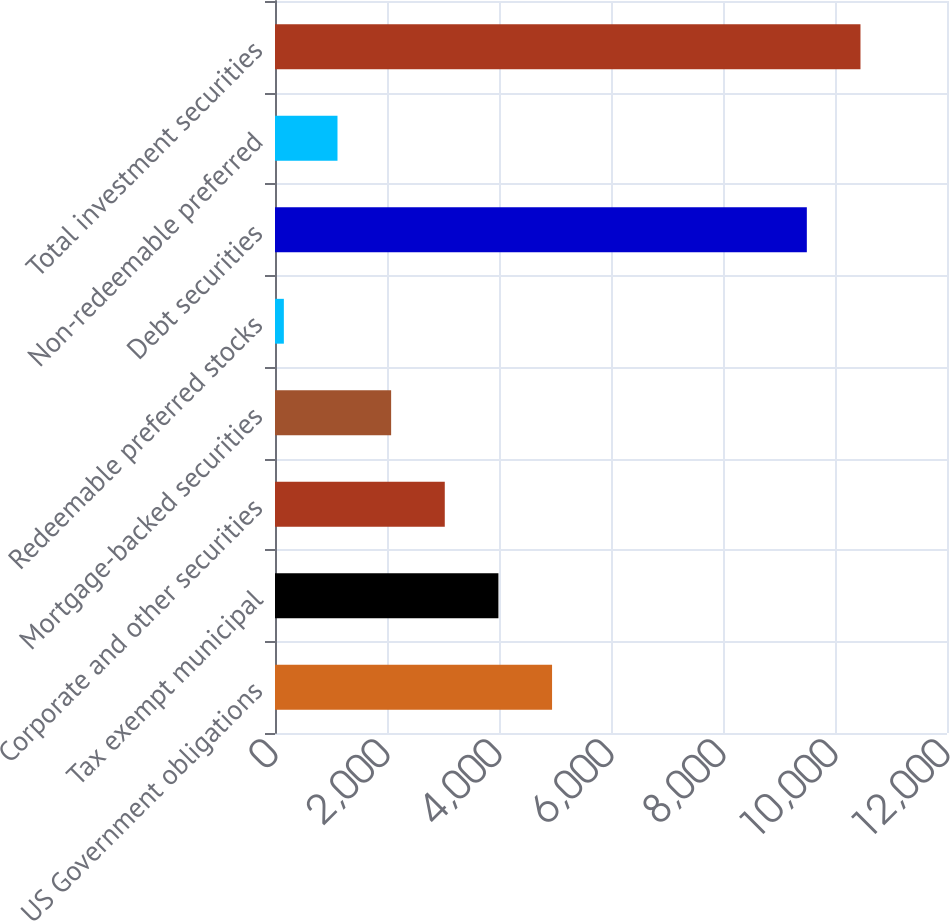<chart> <loc_0><loc_0><loc_500><loc_500><bar_chart><fcel>US Government obligations<fcel>Tax exempt municipal<fcel>Corporate and other securities<fcel>Mortgage-backed securities<fcel>Redeemable preferred stocks<fcel>Debt securities<fcel>Non-redeemable preferred<fcel>Total investment securities<nl><fcel>4947.5<fcel>3989.6<fcel>3031.7<fcel>2073.8<fcel>158<fcel>9497<fcel>1115.9<fcel>10454.9<nl></chart> 